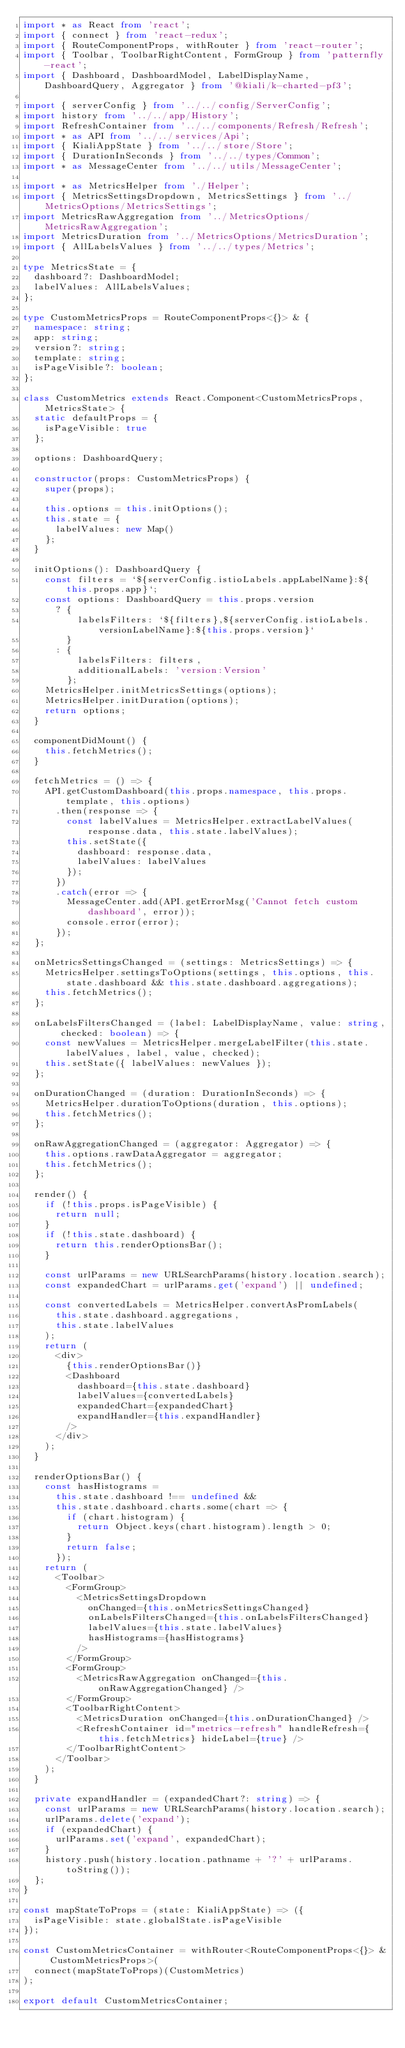Convert code to text. <code><loc_0><loc_0><loc_500><loc_500><_TypeScript_>import * as React from 'react';
import { connect } from 'react-redux';
import { RouteComponentProps, withRouter } from 'react-router';
import { Toolbar, ToolbarRightContent, FormGroup } from 'patternfly-react';
import { Dashboard, DashboardModel, LabelDisplayName, DashboardQuery, Aggregator } from '@kiali/k-charted-pf3';

import { serverConfig } from '../../config/ServerConfig';
import history from '../../app/History';
import RefreshContainer from '../../components/Refresh/Refresh';
import * as API from '../../services/Api';
import { KialiAppState } from '../../store/Store';
import { DurationInSeconds } from '../../types/Common';
import * as MessageCenter from '../../utils/MessageCenter';

import * as MetricsHelper from './Helper';
import { MetricsSettingsDropdown, MetricsSettings } from '../MetricsOptions/MetricsSettings';
import MetricsRawAggregation from '../MetricsOptions/MetricsRawAggregation';
import MetricsDuration from '../MetricsOptions/MetricsDuration';
import { AllLabelsValues } from '../../types/Metrics';

type MetricsState = {
  dashboard?: DashboardModel;
  labelValues: AllLabelsValues;
};

type CustomMetricsProps = RouteComponentProps<{}> & {
  namespace: string;
  app: string;
  version?: string;
  template: string;
  isPageVisible?: boolean;
};

class CustomMetrics extends React.Component<CustomMetricsProps, MetricsState> {
  static defaultProps = {
    isPageVisible: true
  };

  options: DashboardQuery;

  constructor(props: CustomMetricsProps) {
    super(props);

    this.options = this.initOptions();
    this.state = {
      labelValues: new Map()
    };
  }

  initOptions(): DashboardQuery {
    const filters = `${serverConfig.istioLabels.appLabelName}:${this.props.app}`;
    const options: DashboardQuery = this.props.version
      ? {
          labelsFilters: `${filters},${serverConfig.istioLabels.versionLabelName}:${this.props.version}`
        }
      : {
          labelsFilters: filters,
          additionalLabels: 'version:Version'
        };
    MetricsHelper.initMetricsSettings(options);
    MetricsHelper.initDuration(options);
    return options;
  }

  componentDidMount() {
    this.fetchMetrics();
  }

  fetchMetrics = () => {
    API.getCustomDashboard(this.props.namespace, this.props.template, this.options)
      .then(response => {
        const labelValues = MetricsHelper.extractLabelValues(response.data, this.state.labelValues);
        this.setState({
          dashboard: response.data,
          labelValues: labelValues
        });
      })
      .catch(error => {
        MessageCenter.add(API.getErrorMsg('Cannot fetch custom dashboard', error));
        console.error(error);
      });
  };

  onMetricsSettingsChanged = (settings: MetricsSettings) => {
    MetricsHelper.settingsToOptions(settings, this.options, this.state.dashboard && this.state.dashboard.aggregations);
    this.fetchMetrics();
  };

  onLabelsFiltersChanged = (label: LabelDisplayName, value: string, checked: boolean) => {
    const newValues = MetricsHelper.mergeLabelFilter(this.state.labelValues, label, value, checked);
    this.setState({ labelValues: newValues });
  };

  onDurationChanged = (duration: DurationInSeconds) => {
    MetricsHelper.durationToOptions(duration, this.options);
    this.fetchMetrics();
  };

  onRawAggregationChanged = (aggregator: Aggregator) => {
    this.options.rawDataAggregator = aggregator;
    this.fetchMetrics();
  };

  render() {
    if (!this.props.isPageVisible) {
      return null;
    }
    if (!this.state.dashboard) {
      return this.renderOptionsBar();
    }

    const urlParams = new URLSearchParams(history.location.search);
    const expandedChart = urlParams.get('expand') || undefined;

    const convertedLabels = MetricsHelper.convertAsPromLabels(
      this.state.dashboard.aggregations,
      this.state.labelValues
    );
    return (
      <div>
        {this.renderOptionsBar()}
        <Dashboard
          dashboard={this.state.dashboard}
          labelValues={convertedLabels}
          expandedChart={expandedChart}
          expandHandler={this.expandHandler}
        />
      </div>
    );
  }

  renderOptionsBar() {
    const hasHistograms =
      this.state.dashboard !== undefined &&
      this.state.dashboard.charts.some(chart => {
        if (chart.histogram) {
          return Object.keys(chart.histogram).length > 0;
        }
        return false;
      });
    return (
      <Toolbar>
        <FormGroup>
          <MetricsSettingsDropdown
            onChanged={this.onMetricsSettingsChanged}
            onLabelsFiltersChanged={this.onLabelsFiltersChanged}
            labelValues={this.state.labelValues}
            hasHistograms={hasHistograms}
          />
        </FormGroup>
        <FormGroup>
          <MetricsRawAggregation onChanged={this.onRawAggregationChanged} />
        </FormGroup>
        <ToolbarRightContent>
          <MetricsDuration onChanged={this.onDurationChanged} />
          <RefreshContainer id="metrics-refresh" handleRefresh={this.fetchMetrics} hideLabel={true} />
        </ToolbarRightContent>
      </Toolbar>
    );
  }

  private expandHandler = (expandedChart?: string) => {
    const urlParams = new URLSearchParams(history.location.search);
    urlParams.delete('expand');
    if (expandedChart) {
      urlParams.set('expand', expandedChart);
    }
    history.push(history.location.pathname + '?' + urlParams.toString());
  };
}

const mapStateToProps = (state: KialiAppState) => ({
  isPageVisible: state.globalState.isPageVisible
});

const CustomMetricsContainer = withRouter<RouteComponentProps<{}> & CustomMetricsProps>(
  connect(mapStateToProps)(CustomMetrics)
);

export default CustomMetricsContainer;
</code> 